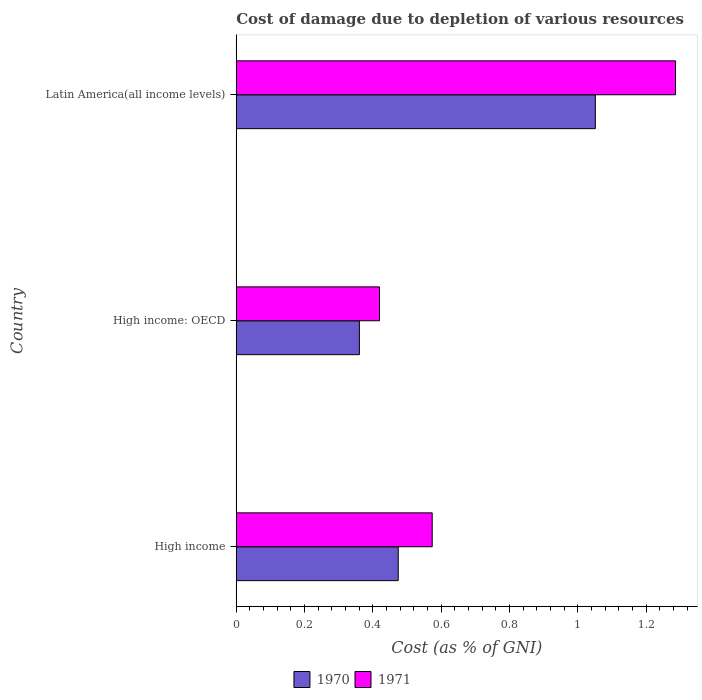Are the number of bars per tick equal to the number of legend labels?
Provide a short and direct response. Yes. Are the number of bars on each tick of the Y-axis equal?
Offer a terse response. Yes. What is the cost of damage caused due to the depletion of various resources in 1971 in Latin America(all income levels)?
Your answer should be very brief. 1.29. Across all countries, what is the maximum cost of damage caused due to the depletion of various resources in 1971?
Offer a very short reply. 1.29. Across all countries, what is the minimum cost of damage caused due to the depletion of various resources in 1970?
Offer a terse response. 0.36. In which country was the cost of damage caused due to the depletion of various resources in 1970 maximum?
Your response must be concise. Latin America(all income levels). In which country was the cost of damage caused due to the depletion of various resources in 1971 minimum?
Your response must be concise. High income: OECD. What is the total cost of damage caused due to the depletion of various resources in 1971 in the graph?
Provide a succinct answer. 2.28. What is the difference between the cost of damage caused due to the depletion of various resources in 1970 in High income and that in High income: OECD?
Your response must be concise. 0.11. What is the difference between the cost of damage caused due to the depletion of various resources in 1970 in Latin America(all income levels) and the cost of damage caused due to the depletion of various resources in 1971 in High income?
Offer a very short reply. 0.48. What is the average cost of damage caused due to the depletion of various resources in 1971 per country?
Provide a short and direct response. 0.76. What is the difference between the cost of damage caused due to the depletion of various resources in 1970 and cost of damage caused due to the depletion of various resources in 1971 in High income?
Your answer should be very brief. -0.1. What is the ratio of the cost of damage caused due to the depletion of various resources in 1971 in High income to that in High income: OECD?
Ensure brevity in your answer.  1.37. Is the cost of damage caused due to the depletion of various resources in 1971 in High income: OECD less than that in Latin America(all income levels)?
Ensure brevity in your answer.  Yes. What is the difference between the highest and the second highest cost of damage caused due to the depletion of various resources in 1971?
Offer a terse response. 0.71. What is the difference between the highest and the lowest cost of damage caused due to the depletion of various resources in 1971?
Ensure brevity in your answer.  0.87. Is the sum of the cost of damage caused due to the depletion of various resources in 1971 in High income: OECD and Latin America(all income levels) greater than the maximum cost of damage caused due to the depletion of various resources in 1970 across all countries?
Ensure brevity in your answer.  Yes. Are all the bars in the graph horizontal?
Provide a short and direct response. Yes. What is the difference between two consecutive major ticks on the X-axis?
Make the answer very short. 0.2. Where does the legend appear in the graph?
Make the answer very short. Bottom center. How are the legend labels stacked?
Provide a short and direct response. Horizontal. What is the title of the graph?
Offer a very short reply. Cost of damage due to depletion of various resources. Does "1984" appear as one of the legend labels in the graph?
Keep it short and to the point. No. What is the label or title of the X-axis?
Offer a very short reply. Cost (as % of GNI). What is the Cost (as % of GNI) in 1970 in High income?
Your answer should be compact. 0.47. What is the Cost (as % of GNI) of 1971 in High income?
Keep it short and to the point. 0.57. What is the Cost (as % of GNI) in 1970 in High income: OECD?
Keep it short and to the point. 0.36. What is the Cost (as % of GNI) in 1971 in High income: OECD?
Your response must be concise. 0.42. What is the Cost (as % of GNI) of 1970 in Latin America(all income levels)?
Your response must be concise. 1.05. What is the Cost (as % of GNI) of 1971 in Latin America(all income levels)?
Provide a short and direct response. 1.29. Across all countries, what is the maximum Cost (as % of GNI) in 1970?
Your response must be concise. 1.05. Across all countries, what is the maximum Cost (as % of GNI) of 1971?
Offer a very short reply. 1.29. Across all countries, what is the minimum Cost (as % of GNI) in 1970?
Ensure brevity in your answer.  0.36. Across all countries, what is the minimum Cost (as % of GNI) of 1971?
Make the answer very short. 0.42. What is the total Cost (as % of GNI) in 1970 in the graph?
Give a very brief answer. 1.89. What is the total Cost (as % of GNI) in 1971 in the graph?
Give a very brief answer. 2.28. What is the difference between the Cost (as % of GNI) of 1970 in High income and that in High income: OECD?
Provide a succinct answer. 0.11. What is the difference between the Cost (as % of GNI) in 1971 in High income and that in High income: OECD?
Your answer should be very brief. 0.15. What is the difference between the Cost (as % of GNI) of 1970 in High income and that in Latin America(all income levels)?
Ensure brevity in your answer.  -0.58. What is the difference between the Cost (as % of GNI) of 1971 in High income and that in Latin America(all income levels)?
Offer a very short reply. -0.71. What is the difference between the Cost (as % of GNI) of 1970 in High income: OECD and that in Latin America(all income levels)?
Give a very brief answer. -0.69. What is the difference between the Cost (as % of GNI) of 1971 in High income: OECD and that in Latin America(all income levels)?
Make the answer very short. -0.87. What is the difference between the Cost (as % of GNI) of 1970 in High income and the Cost (as % of GNI) of 1971 in High income: OECD?
Provide a succinct answer. 0.05. What is the difference between the Cost (as % of GNI) of 1970 in High income and the Cost (as % of GNI) of 1971 in Latin America(all income levels)?
Give a very brief answer. -0.81. What is the difference between the Cost (as % of GNI) in 1970 in High income: OECD and the Cost (as % of GNI) in 1971 in Latin America(all income levels)?
Offer a terse response. -0.93. What is the average Cost (as % of GNI) in 1970 per country?
Offer a terse response. 0.63. What is the average Cost (as % of GNI) of 1971 per country?
Your answer should be compact. 0.76. What is the difference between the Cost (as % of GNI) in 1970 and Cost (as % of GNI) in 1971 in High income?
Provide a short and direct response. -0.1. What is the difference between the Cost (as % of GNI) in 1970 and Cost (as % of GNI) in 1971 in High income: OECD?
Offer a very short reply. -0.06. What is the difference between the Cost (as % of GNI) in 1970 and Cost (as % of GNI) in 1971 in Latin America(all income levels)?
Keep it short and to the point. -0.23. What is the ratio of the Cost (as % of GNI) of 1970 in High income to that in High income: OECD?
Your answer should be very brief. 1.32. What is the ratio of the Cost (as % of GNI) in 1971 in High income to that in High income: OECD?
Provide a short and direct response. 1.37. What is the ratio of the Cost (as % of GNI) in 1970 in High income to that in Latin America(all income levels)?
Your answer should be very brief. 0.45. What is the ratio of the Cost (as % of GNI) of 1971 in High income to that in Latin America(all income levels)?
Your answer should be very brief. 0.45. What is the ratio of the Cost (as % of GNI) in 1970 in High income: OECD to that in Latin America(all income levels)?
Provide a succinct answer. 0.34. What is the ratio of the Cost (as % of GNI) of 1971 in High income: OECD to that in Latin America(all income levels)?
Ensure brevity in your answer.  0.33. What is the difference between the highest and the second highest Cost (as % of GNI) of 1970?
Your answer should be very brief. 0.58. What is the difference between the highest and the second highest Cost (as % of GNI) in 1971?
Offer a very short reply. 0.71. What is the difference between the highest and the lowest Cost (as % of GNI) in 1970?
Ensure brevity in your answer.  0.69. What is the difference between the highest and the lowest Cost (as % of GNI) in 1971?
Ensure brevity in your answer.  0.87. 